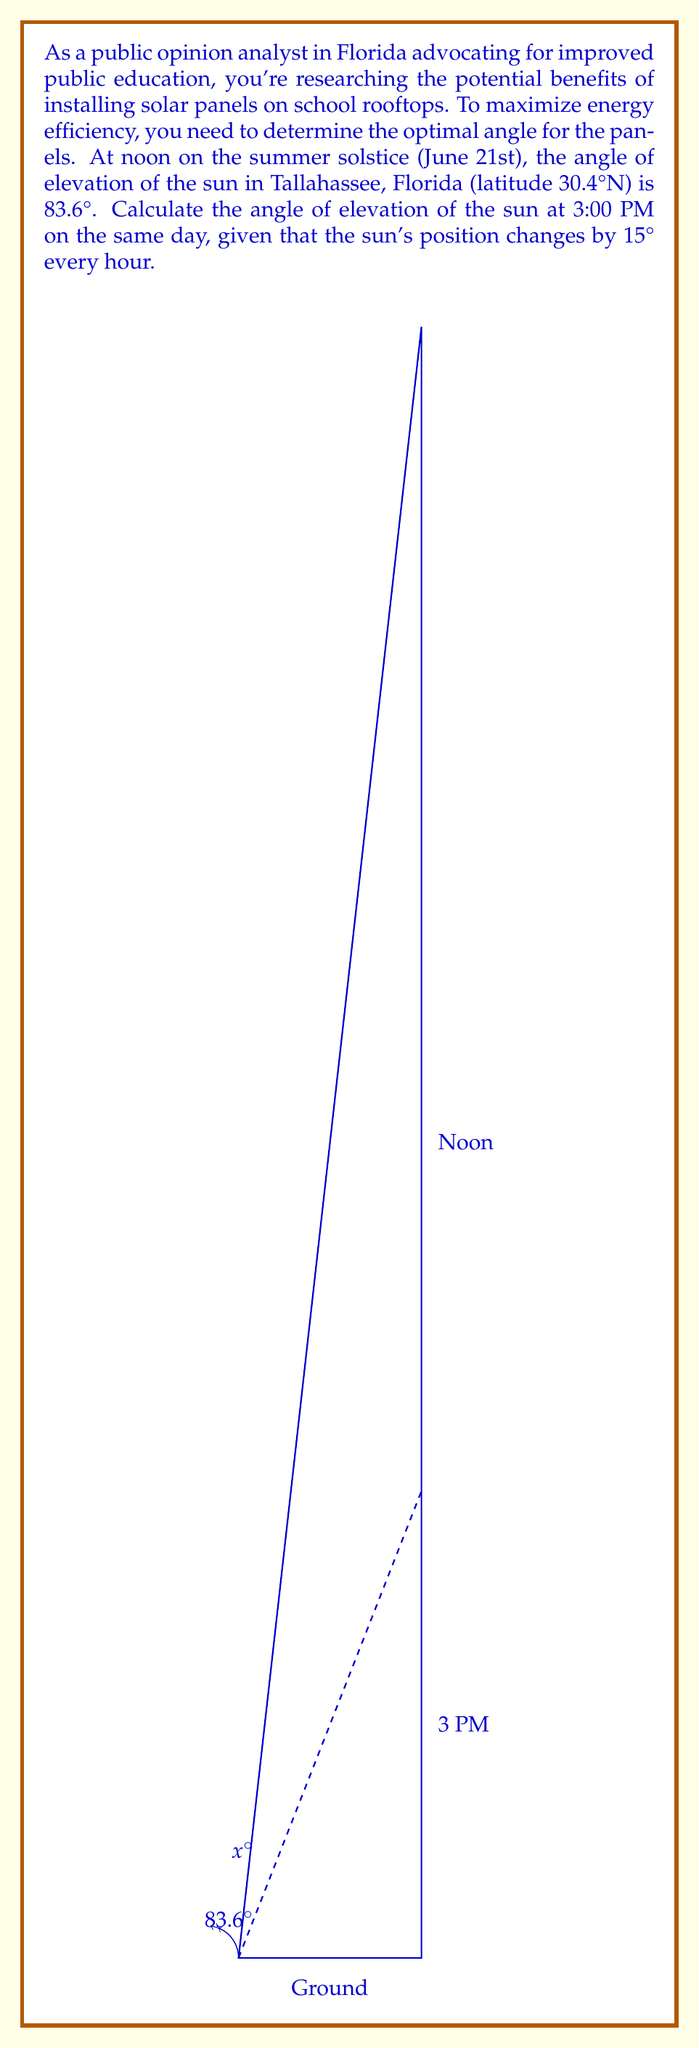Can you answer this question? To solve this problem, let's follow these steps:

1) First, we need to calculate how many hours have passed between noon and 3:00 PM:
   3:00 PM - 12:00 PM = 3 hours

2) We know that the sun's position changes by 15° every hour. So in 3 hours, it will change by:
   $15° \times 3 = 45°$

3) The angle of elevation at noon is 83.6°. To find the angle at 3:00 PM, we subtract 45° from this:
   $83.6° - 45° = 38.6°$

4) However, this is not our final answer. The question asks for the angle of elevation, which is measured from the horizontal. The angle we calculated (38.6°) is measured from the vertical.

5) To convert this to an angle of elevation, we need to subtract it from 90°:
   $90° - 38.6° = 51.4°$

Therefore, the angle of elevation of the sun at 3:00 PM on the summer solstice in Tallahassee, Florida is 51.4°.

This information is crucial for determining the optimal angle for solar panels on school rooftops, which could lead to significant energy savings for the education system in Florida.
Answer: $51.4°$ 